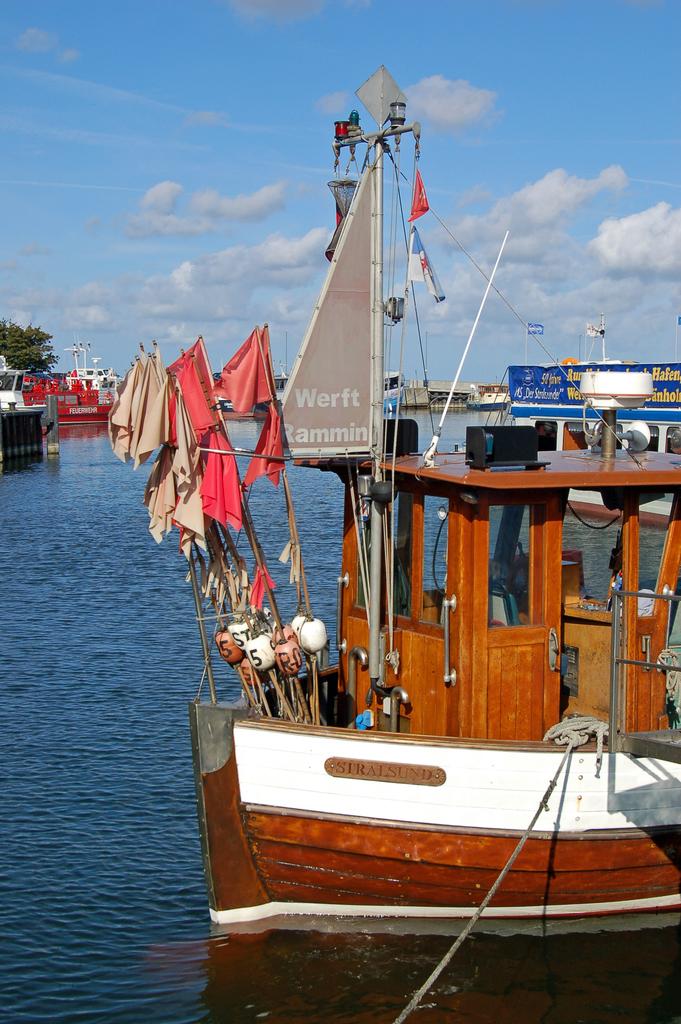Is this the only boat?
Your answer should be very brief. Answering does not require reading text in the image. 